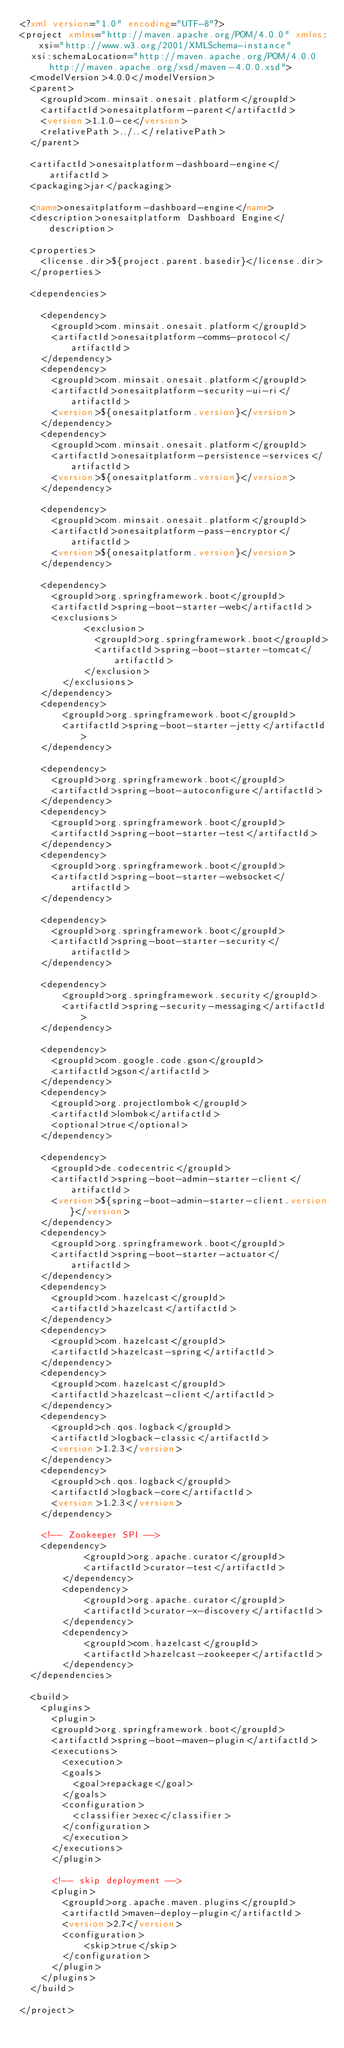Convert code to text. <code><loc_0><loc_0><loc_500><loc_500><_XML_><?xml version="1.0" encoding="UTF-8"?>
<project xmlns="http://maven.apache.org/POM/4.0.0" xmlns:xsi="http://www.w3.org/2001/XMLSchema-instance"
	xsi:schemaLocation="http://maven.apache.org/POM/4.0.0 http://maven.apache.org/xsd/maven-4.0.0.xsd">
	<modelVersion>4.0.0</modelVersion>
	<parent>
		<groupId>com.minsait.onesait.platform</groupId>
		<artifactId>onesaitplatform-parent</artifactId>
		<version>1.1.0-ce</version>
		<relativePath>../..</relativePath>
	</parent>
	
	<artifactId>onesaitplatform-dashboard-engine</artifactId>
	<packaging>jar</packaging>

	<name>onesaitplatform-dashboard-engine</name>
	<description>onesaitplatform Dashboard Engine</description>
		
	<properties>
    <license.dir>${project.parent.basedir}</license.dir>
	</properties>

	<dependencies>
		
		<dependency>
			<groupId>com.minsait.onesait.platform</groupId>
			<artifactId>onesaitplatform-comms-protocol</artifactId>
		</dependency>
		<dependency>
			<groupId>com.minsait.onesait.platform</groupId>
			<artifactId>onesaitplatform-security-ui-ri</artifactId>
			<version>${onesaitplatform.version}</version>
		</dependency>
		<dependency>
			<groupId>com.minsait.onesait.platform</groupId>
			<artifactId>onesaitplatform-persistence-services</artifactId>
			<version>${onesaitplatform.version}</version>
		</dependency>
		
		<dependency>
			<groupId>com.minsait.onesait.platform</groupId>
			<artifactId>onesaitplatform-pass-encryptor</artifactId>
			<version>${onesaitplatform.version}</version>
		</dependency>		
		
		<dependency>
			<groupId>org.springframework.boot</groupId>
			<artifactId>spring-boot-starter-web</artifactId>
			<exclusions>
      			<exclusion>
         			<groupId>org.springframework.boot</groupId>
         			<artifactId>spring-boot-starter-tomcat</artifactId>
      			</exclusion>
   			</exclusions>
		</dependency>
		<dependency>
   			<groupId>org.springframework.boot</groupId>
   			<artifactId>spring-boot-starter-jetty</artifactId>
		</dependency>
		
		<dependency>
			<groupId>org.springframework.boot</groupId>
			<artifactId>spring-boot-autoconfigure</artifactId>
		</dependency>
		<dependency>
			<groupId>org.springframework.boot</groupId>
			<artifactId>spring-boot-starter-test</artifactId>
		</dependency>
		<dependency>
			<groupId>org.springframework.boot</groupId>
			<artifactId>spring-boot-starter-websocket</artifactId>
		</dependency>
		
		<dependency>
			<groupId>org.springframework.boot</groupId>
			<artifactId>spring-boot-starter-security</artifactId>
		</dependency>
		
		<dependency>
		    <groupId>org.springframework.security</groupId>
		    <artifactId>spring-security-messaging</artifactId>
		</dependency>
		
		<dependency>
			<groupId>com.google.code.gson</groupId>
			<artifactId>gson</artifactId>
		</dependency>
		<dependency>
			<groupId>org.projectlombok</groupId>
			<artifactId>lombok</artifactId>
			<optional>true</optional>
		</dependency>				
		
		<dependency>
			<groupId>de.codecentric</groupId>
			<artifactId>spring-boot-admin-starter-client</artifactId>
			<version>${spring-boot-admin-starter-client.version}</version>
		</dependency>
		<dependency>
			<groupId>org.springframework.boot</groupId>
			<artifactId>spring-boot-starter-actuator</artifactId>
		</dependency>
		<dependency>
			<groupId>com.hazelcast</groupId>
			<artifactId>hazelcast</artifactId>
		</dependency>
		<dependency>
			<groupId>com.hazelcast</groupId>
			<artifactId>hazelcast-spring</artifactId>
		</dependency>
		<dependency>
			<groupId>com.hazelcast</groupId>
			<artifactId>hazelcast-client</artifactId>
		</dependency>
		<dependency>
			<groupId>ch.qos.logback</groupId>
			<artifactId>logback-classic</artifactId>
			<version>1.2.3</version>
		</dependency>
		<dependency>
			<groupId>ch.qos.logback</groupId>
			<artifactId>logback-core</artifactId>
			<version>1.2.3</version>
		</dependency>
		
		<!-- Zookeeper SPI -->
		<dependency>
            <groupId>org.apache.curator</groupId>
            <artifactId>curator-test</artifactId>
        </dependency>
        <dependency>
            <groupId>org.apache.curator</groupId>
            <artifactId>curator-x-discovery</artifactId>
        </dependency>
        <dependency>
            <groupId>com.hazelcast</groupId>
            <artifactId>hazelcast-zookeeper</artifactId>
        </dependency>
	</dependencies>	

	<build>
		<plugins>
		  <plugin>
			<groupId>org.springframework.boot</groupId>
			<artifactId>spring-boot-maven-plugin</artifactId>
			<executions>
			  <execution>
				<goals>
				  <goal>repackage</goal>
				</goals>
				<configuration>
				  <classifier>exec</classifier>
				</configuration>
			  </execution>
			</executions>
		  </plugin>
		    
		  <!-- skip deployment -->	
		  <plugin>
		    <groupId>org.apache.maven.plugins</groupId>
		    <artifactId>maven-deploy-plugin</artifactId>
		    <version>2.7</version>
		    <configuration>
		        <skip>true</skip>
		    </configuration>
		  </plugin>		    		  
		</plugins>
  </build>

</project>
</code> 